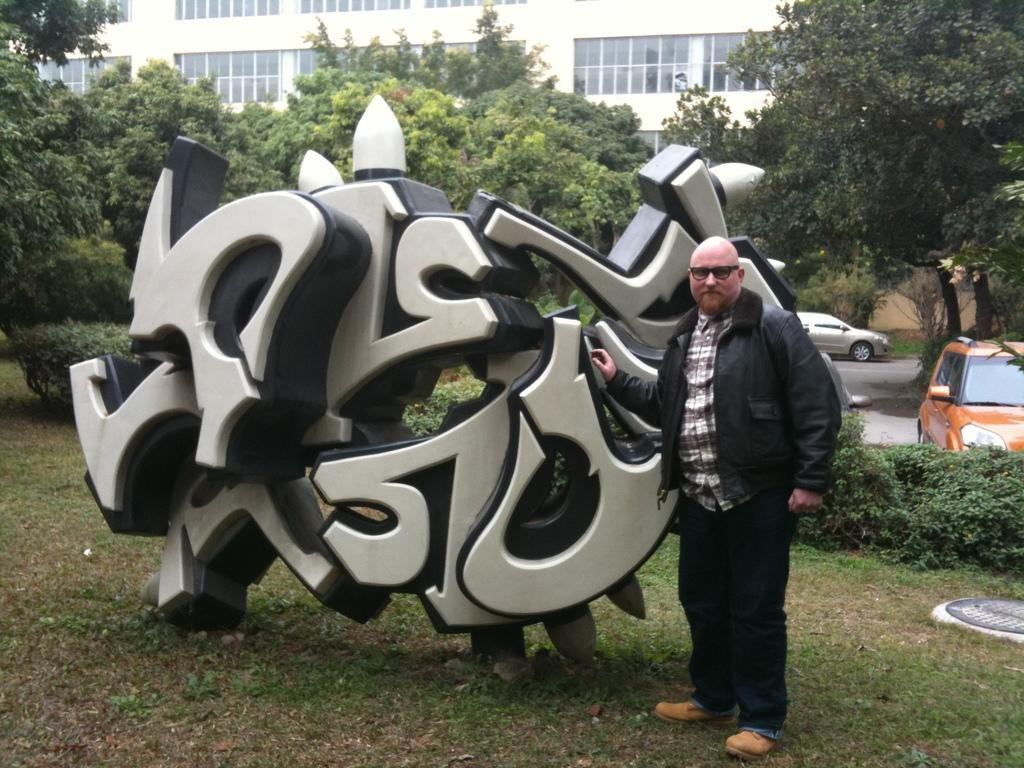What type of structure is on the grass in the image? There is a carving architecture on the grass. Who is present near the carving architecture? There is a man beside the carving architecture. What can be seen in the background of the image? There are trees, buildings, and cars in the background of the image. What type of engine is being developed in the image? There is no reference to an engine or development in the image; it features a carving architecture, a man, and a background with trees, buildings, and cars. 